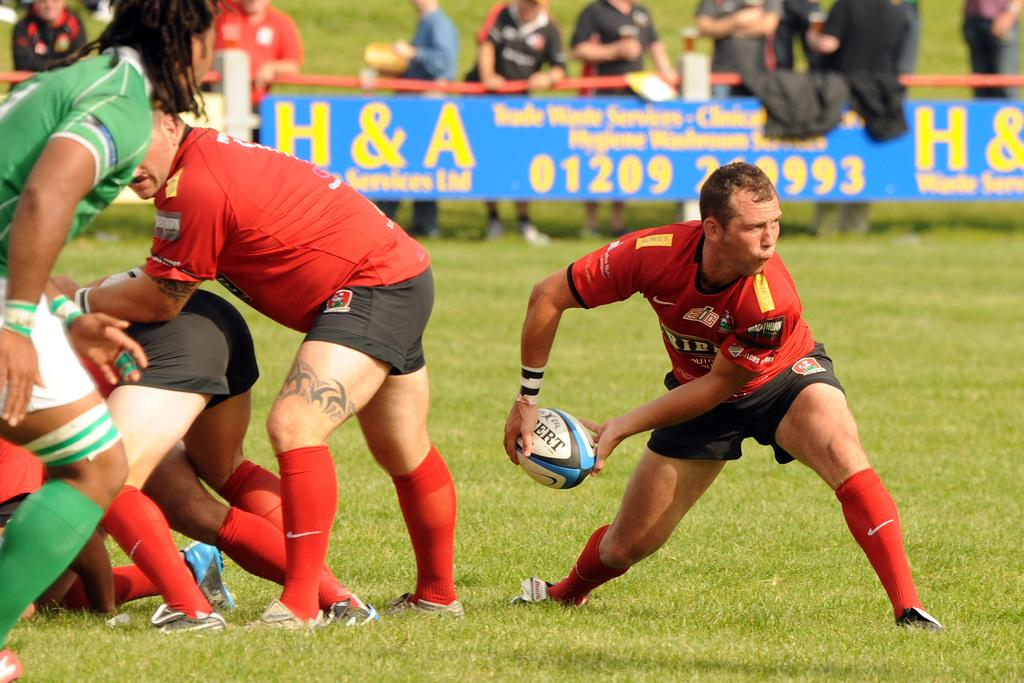What is happening in the image involving a group of people? The group of people are playing American football. Can you describe the activity taking place in the image? The group of people are engaged in a game of American football, which involves passing, catching, and running with an oval-shaped ball. What type of bridge can be seen in the image? There is no bridge present in the image; it features a group of people playing American football. 